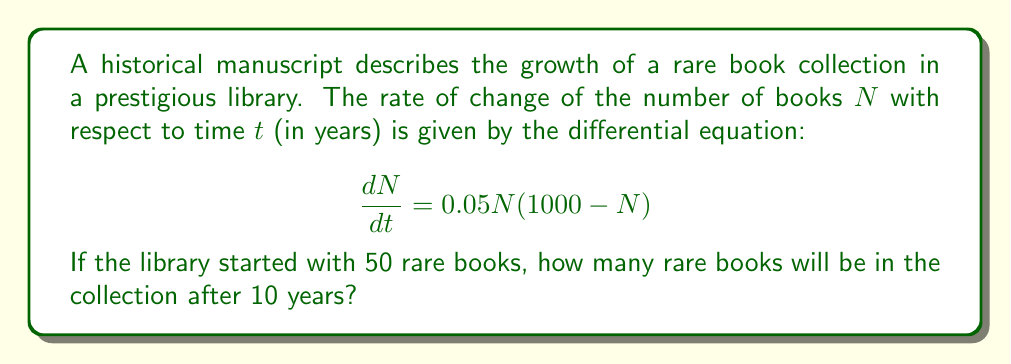Teach me how to tackle this problem. To solve this first-order nonlinear differential equation, we'll use the method of separation of variables:

1) Separate the variables:
   $$\frac{dN}{0.05N(1000 - N)} = dt$$

2) Integrate both sides:
   $$\int \frac{dN}{0.05N(1000 - N)} = \int dt$$

3) The left side can be integrated using partial fractions:
   $$\frac{1}{50} \int (\frac{1}{N} + \frac{1}{1000-N}) dN = t + C$$

4) Integrating:
   $$\frac{1}{50} [\ln|N| - \ln|1000-N|] = t + C$$

5) Simplify:
   $$\ln|\frac{N}{1000-N}| = 50t + C'$$

6) Exponentiate both sides:
   $$\frac{N}{1000-N} = Ae^{50t}$$, where $A = e^{C'}$

7) Solve for N:
   $$N = \frac{1000Ae^{50t}}{1 + Ae^{50t}}$$

8) Use the initial condition: $N(0) = 50$
   $$50 = \frac{1000A}{1 + A}$$
   $$A = \frac{1}{19}$$

9) Substitute back into the general solution:
   $$N = \frac{1000(1/19)e^{50t}}{1 + (1/19)e^{50t}}$$

10) Simplify:
    $$N = \frac{1000e^{50t}}{19 + e^{50t}}$$

11) Evaluate at $t = 10$:
    $$N(10) = \frac{1000e^{500}}{19 + e^{500}} \approx 999.99$$
Answer: $1000$ books (rounded to the nearest whole number) 